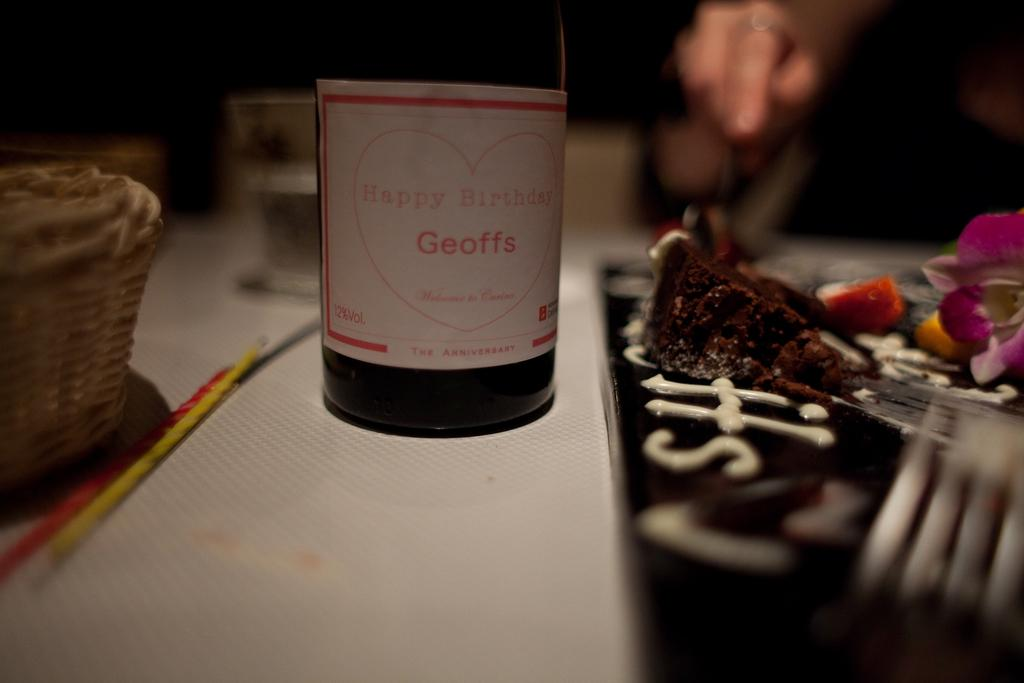<image>
Offer a succinct explanation of the picture presented. A bottle of wine is labeled happy Birthday Geoffe inside of a red heart 